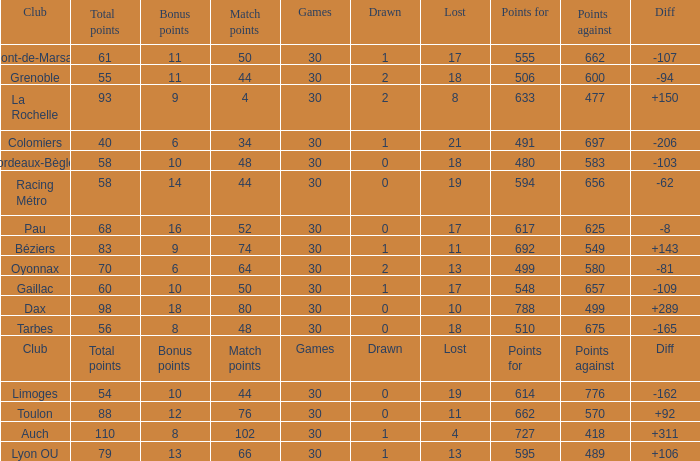What is the amount of match points for a club that lost 18 and has 11 bonus points? 44.0. 